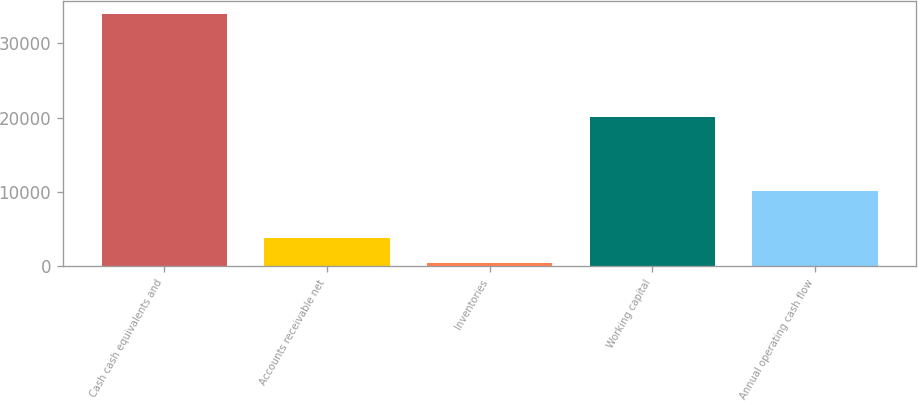<chart> <loc_0><loc_0><loc_500><loc_500><bar_chart><fcel>Cash cash equivalents and<fcel>Accounts receivable net<fcel>Inventories<fcel>Working capital<fcel>Annual operating cash flow<nl><fcel>33992<fcel>3808.7<fcel>455<fcel>20049<fcel>10159<nl></chart> 